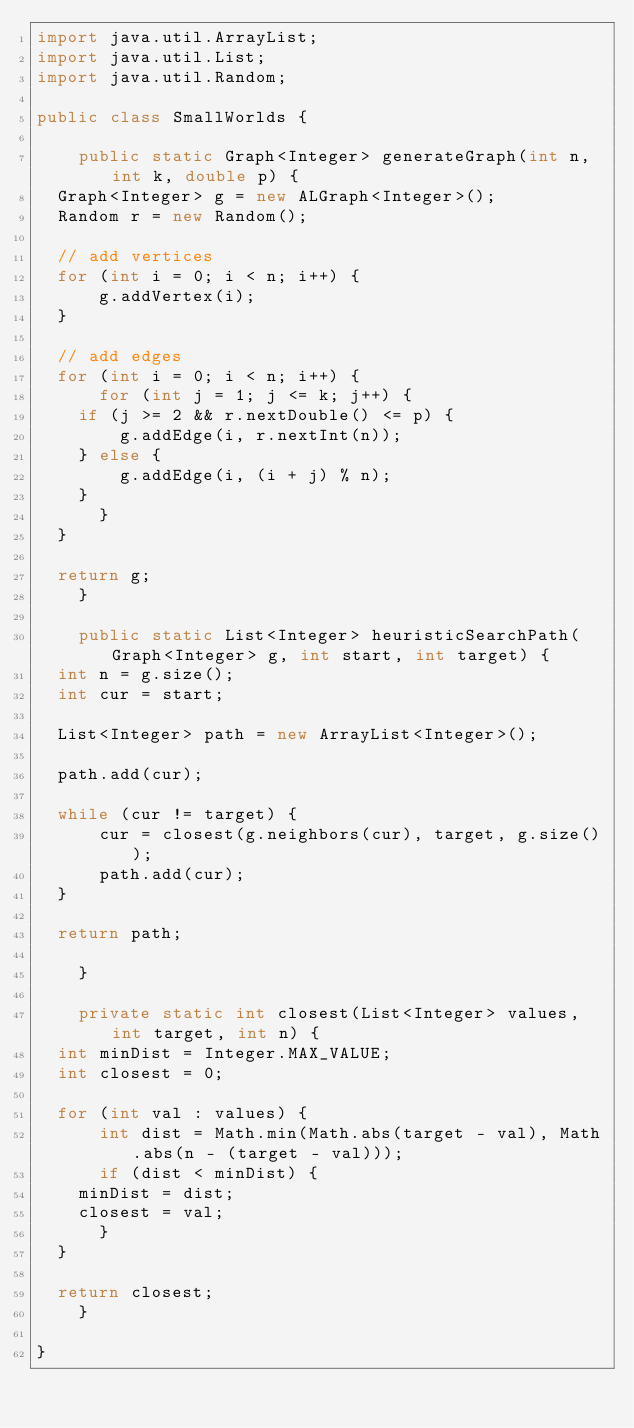Convert code to text. <code><loc_0><loc_0><loc_500><loc_500><_Java_>import java.util.ArrayList;
import java.util.List;
import java.util.Random;

public class SmallWorlds {
        
    public static Graph<Integer> generateGraph(int n, int k, double p) {
	Graph<Integer> g = new ALGraph<Integer>();
	Random r = new Random();

	// add vertices
	for (int i = 0; i < n; i++) {
	    g.addVertex(i);
	}

	// add edges
	for (int i = 0; i < n; i++) {
	    for (int j = 1; j <= k; j++) {
		if (j >= 2 && r.nextDouble() <= p) {
		    g.addEdge(i, r.nextInt(n));
		} else {
		    g.addEdge(i, (i + j) % n);
		}
	    }
	}

	return g;
    }

    public static List<Integer> heuristicSearchPath(Graph<Integer> g, int start, int target) {
	int n = g.size();
	int cur = start;

	List<Integer> path = new ArrayList<Integer>();

	path.add(cur);

	while (cur != target) {
	    cur = closest(g.neighbors(cur), target, g.size());
	    path.add(cur);
	}

	return path;
	
    }

    private static int closest(List<Integer> values, int target, int n) {
	int minDist = Integer.MAX_VALUE;
	int closest = 0;

	for (int val : values) {
	    int dist = Math.min(Math.abs(target - val), Math.abs(n - (target - val)));
	    if (dist < minDist) {
		minDist = dist;
		closest = val;
	    }
	}

	return closest;
    }

}
</code> 